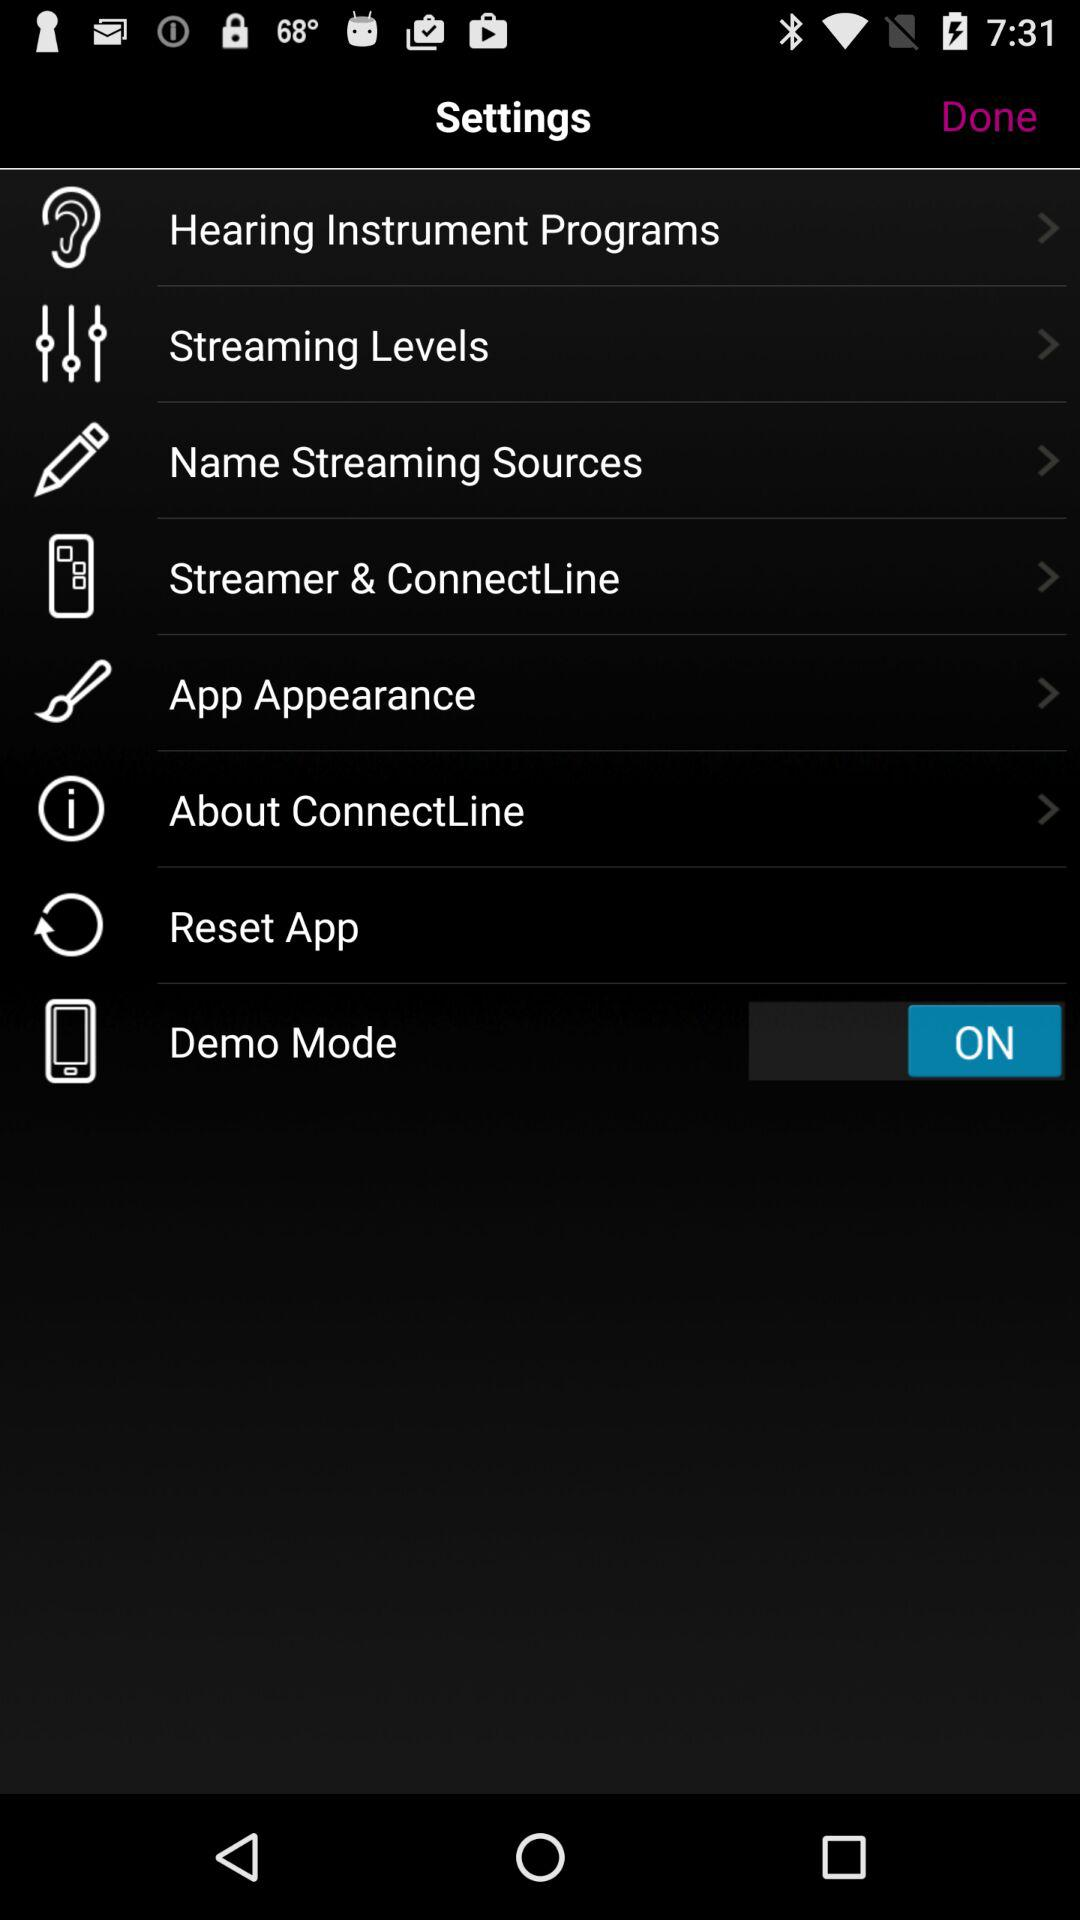How many items are there in the Settings menu?
Answer the question using a single word or phrase. 8 